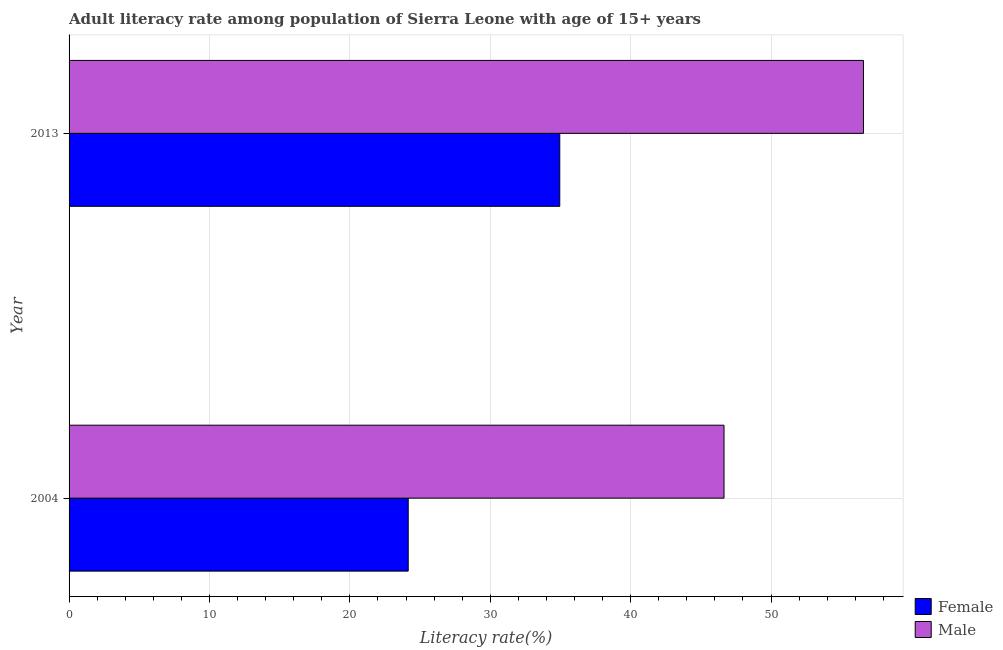How many bars are there on the 1st tick from the bottom?
Ensure brevity in your answer.  2. What is the label of the 2nd group of bars from the top?
Your response must be concise. 2004. What is the female adult literacy rate in 2013?
Provide a short and direct response. 34.95. Across all years, what is the maximum male adult literacy rate?
Offer a terse response. 56.59. Across all years, what is the minimum female adult literacy rate?
Offer a terse response. 24.16. In which year was the male adult literacy rate maximum?
Your answer should be very brief. 2013. What is the total female adult literacy rate in the graph?
Your answer should be compact. 59.11. What is the difference between the female adult literacy rate in 2004 and that in 2013?
Your answer should be compact. -10.79. What is the difference between the female adult literacy rate in 2004 and the male adult literacy rate in 2013?
Provide a succinct answer. -32.43. What is the average female adult literacy rate per year?
Ensure brevity in your answer.  29.56. In the year 2013, what is the difference between the female adult literacy rate and male adult literacy rate?
Make the answer very short. -21.63. What is the ratio of the male adult literacy rate in 2004 to that in 2013?
Your response must be concise. 0.82. Is the difference between the male adult literacy rate in 2004 and 2013 greater than the difference between the female adult literacy rate in 2004 and 2013?
Provide a short and direct response. Yes. What does the 2nd bar from the top in 2013 represents?
Provide a succinct answer. Female. How many years are there in the graph?
Provide a short and direct response. 2. Where does the legend appear in the graph?
Give a very brief answer. Bottom right. How many legend labels are there?
Offer a terse response. 2. How are the legend labels stacked?
Your answer should be very brief. Vertical. What is the title of the graph?
Give a very brief answer. Adult literacy rate among population of Sierra Leone with age of 15+ years. Does "IMF concessional" appear as one of the legend labels in the graph?
Give a very brief answer. No. What is the label or title of the X-axis?
Offer a terse response. Literacy rate(%). What is the label or title of the Y-axis?
Provide a short and direct response. Year. What is the Literacy rate(%) of Female in 2004?
Your answer should be very brief. 24.16. What is the Literacy rate(%) of Male in 2004?
Your answer should be compact. 46.65. What is the Literacy rate(%) of Female in 2013?
Your answer should be compact. 34.95. What is the Literacy rate(%) of Male in 2013?
Make the answer very short. 56.59. Across all years, what is the maximum Literacy rate(%) in Female?
Give a very brief answer. 34.95. Across all years, what is the maximum Literacy rate(%) in Male?
Your answer should be very brief. 56.59. Across all years, what is the minimum Literacy rate(%) in Female?
Give a very brief answer. 24.16. Across all years, what is the minimum Literacy rate(%) in Male?
Give a very brief answer. 46.65. What is the total Literacy rate(%) in Female in the graph?
Your answer should be very brief. 59.11. What is the total Literacy rate(%) of Male in the graph?
Ensure brevity in your answer.  103.24. What is the difference between the Literacy rate(%) of Female in 2004 and that in 2013?
Ensure brevity in your answer.  -10.79. What is the difference between the Literacy rate(%) of Male in 2004 and that in 2013?
Offer a very short reply. -9.93. What is the difference between the Literacy rate(%) of Female in 2004 and the Literacy rate(%) of Male in 2013?
Keep it short and to the point. -32.43. What is the average Literacy rate(%) in Female per year?
Make the answer very short. 29.56. What is the average Literacy rate(%) of Male per year?
Make the answer very short. 51.62. In the year 2004, what is the difference between the Literacy rate(%) in Female and Literacy rate(%) in Male?
Ensure brevity in your answer.  -22.5. In the year 2013, what is the difference between the Literacy rate(%) of Female and Literacy rate(%) of Male?
Your answer should be very brief. -21.63. What is the ratio of the Literacy rate(%) of Female in 2004 to that in 2013?
Your answer should be compact. 0.69. What is the ratio of the Literacy rate(%) in Male in 2004 to that in 2013?
Offer a terse response. 0.82. What is the difference between the highest and the second highest Literacy rate(%) in Female?
Give a very brief answer. 10.79. What is the difference between the highest and the second highest Literacy rate(%) of Male?
Provide a succinct answer. 9.93. What is the difference between the highest and the lowest Literacy rate(%) of Female?
Ensure brevity in your answer.  10.79. What is the difference between the highest and the lowest Literacy rate(%) in Male?
Ensure brevity in your answer.  9.93. 